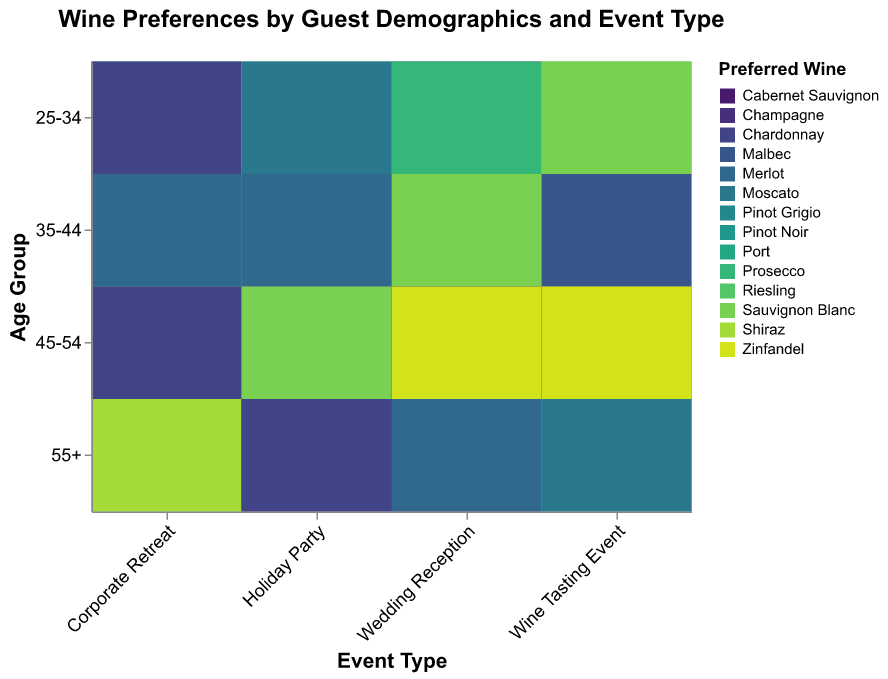Which age group prefers Champagne at a Wine Tasting Event? Look for the part of the heatmap that intersects the "Wine Tasting Event" column with the "Champagne" color code. The age group corresponding to the intersection should be visible.
Answer: 45-54 What is the preferred wine for the 55+ age group at Holiday Parties? Find the part of the heatmap that intersects the "Holiday Party" column and the "55+" row, then check the color and corresponding wine type at this intersection.
Answer: Cabernet Sauvignon How do wine preferences differ between high-income guests aged 25-34 at Corporate Retreats and Wedding Receptions? Identify the intersections of the "25-34" row with "Corporate Retreat" and "Wedding Reception" columns, then compare the colors and their wine types for high-income groups.
Answer: Corporate Retreat: Moscato, Wedding Reception: Chardonnay Which event type has the highest preference for Merlot among the 35-44 age group? Find the "Merlot" color code in the heatmap and locate the event types for the "35-44" row. Check which column has Merlot for this age group.
Answer: Corporate Retreat What is the preferred wine for medium-income guests aged 45-54 at Wedding Receptions? Locate the intersection of the "Wedding Reception" column and the "45-54" row, and identify the color for the medium-income group in that intersection.
Answer: Zinfandel How does the preferred wine for the 45-54 age group differ between high and medium incomes at Wine Tasting Events? Identify the intersections of the "45-54" row with "Wine Tasting Event" column for both high and medium incomes. Check the corresponding wines at these intersections.
Answer: High income: Champagne, Medium income: Zinfandel Which preferred wine is shared by both 25-34 and 55+ age groups at Corporate Retreats? Look at the "Corporate Retreat" column and identify the wines for both "25-34" and "55+" age groups. Find the common wine type, if any, between these groups.
Answer: None Are there any age groups at Holiday Parties where the preferred wines for high and medium income groups are the same? Check each age group's intersections for the "Holiday Party" column for both high and medium incomes. Compare the wine types to identify if they are the same.
Answer: No What is the predominant wine preference for high-income guests aged 35-44 across all event types? Find the "35-44" row for each event type, then identify the colors and wine preferences for high-income groups. Determine if there is a recurring wine type.
Answer: Pinot Grigio 